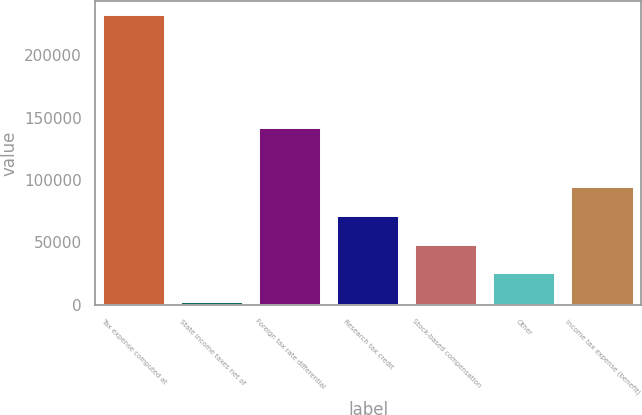<chart> <loc_0><loc_0><loc_500><loc_500><bar_chart><fcel>Tax expense computed at<fcel>State income taxes net of<fcel>Foreign tax rate differential<fcel>Research tax credit<fcel>Stock-based compensation<fcel>Other<fcel>Income tax expense (benefit)<nl><fcel>232189<fcel>2302<fcel>142071<fcel>71268.1<fcel>48279.4<fcel>25290.7<fcel>94256.8<nl></chart> 